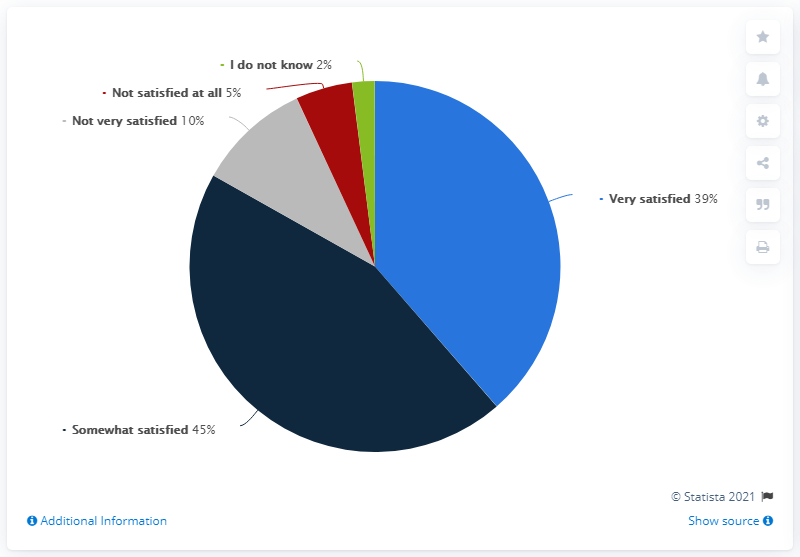Indicate a few pertinent items in this graphic. According to the survey results, 84% of the participants reported being at least somewhat satisfied. The survey found that 39% of the participants were very satisfied with their current job. 